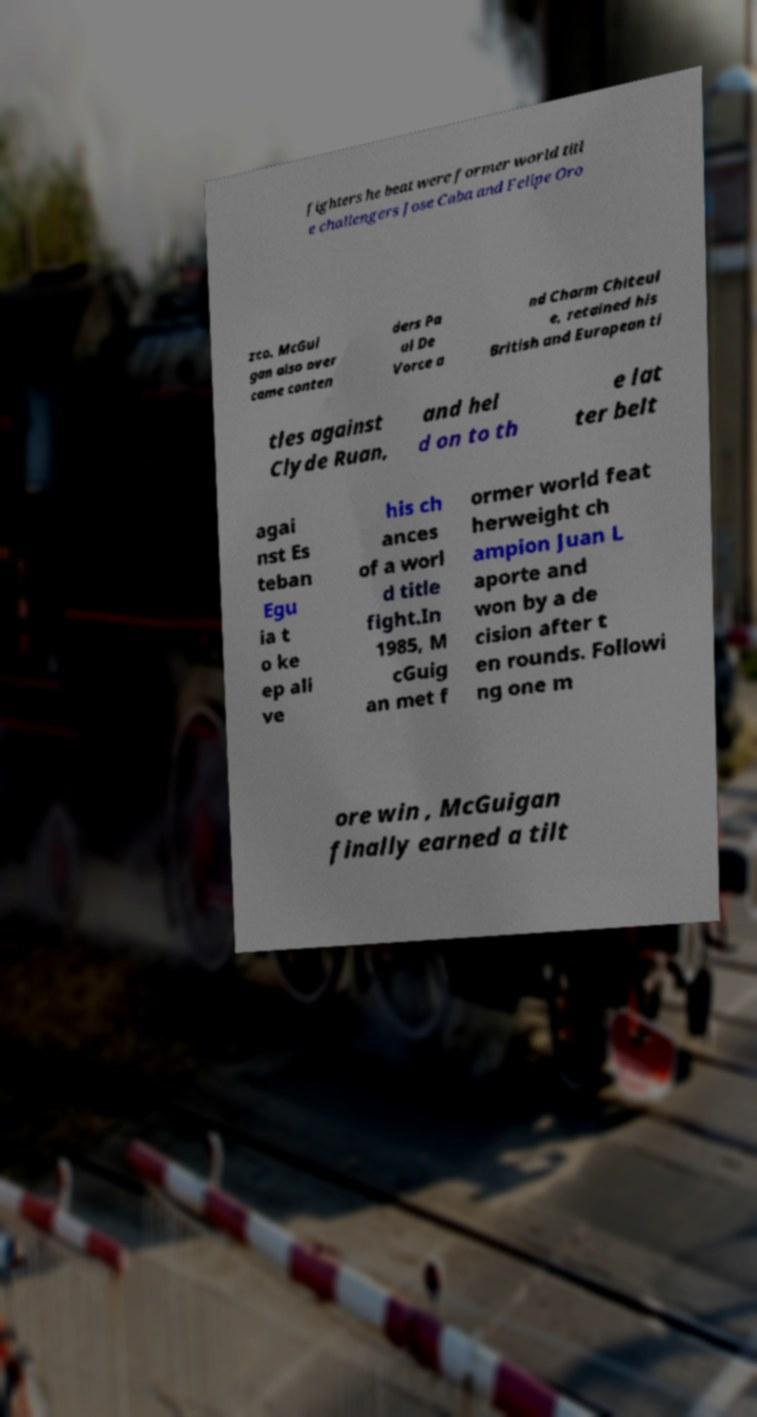Could you assist in decoding the text presented in this image and type it out clearly? fighters he beat were former world titl e challengers Jose Caba and Felipe Oro zco. McGui gan also over came conten ders Pa ul De Vorce a nd Charm Chiteul e, retained his British and European ti tles against Clyde Ruan, and hel d on to th e lat ter belt agai nst Es teban Egu ia t o ke ep ali ve his ch ances of a worl d title fight.In 1985, M cGuig an met f ormer world feat herweight ch ampion Juan L aporte and won by a de cision after t en rounds. Followi ng one m ore win , McGuigan finally earned a tilt 